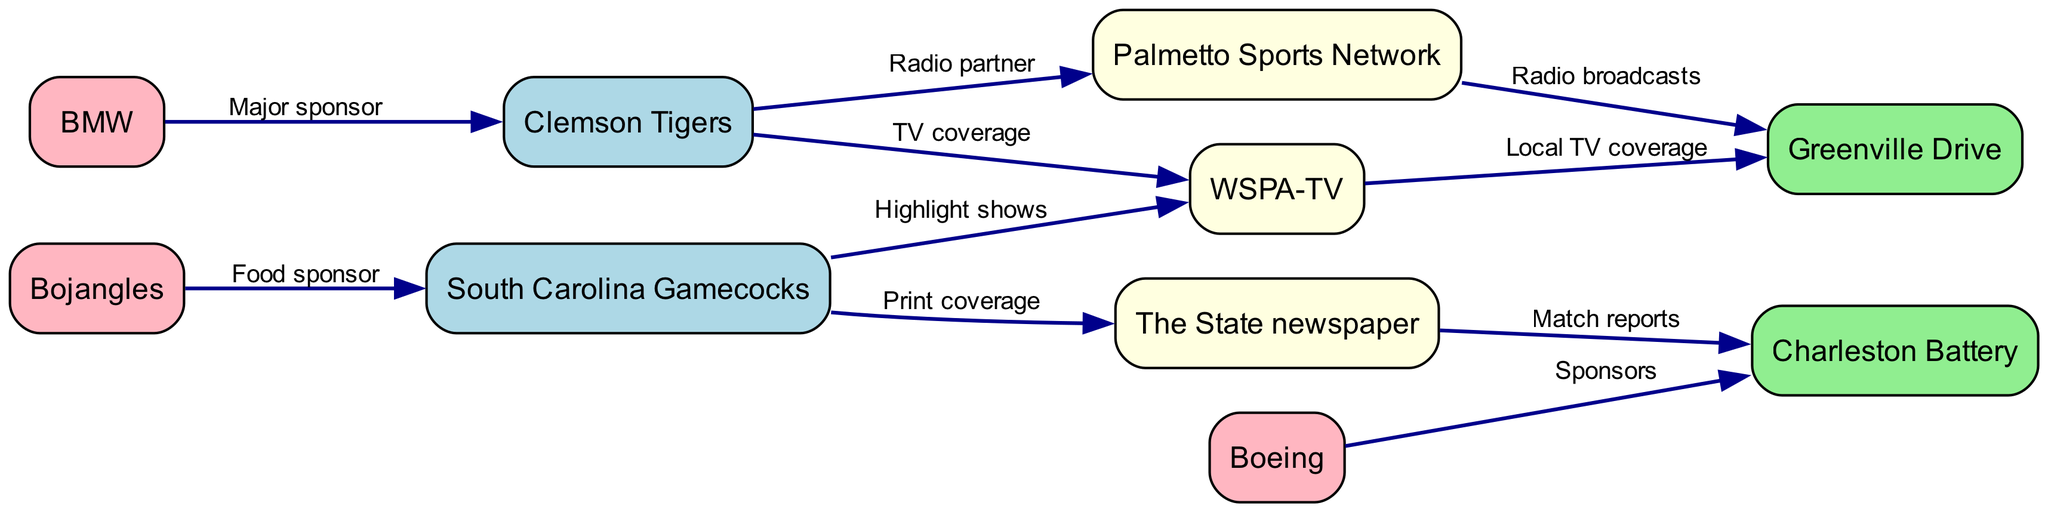What teams are covered by WSPA-TV? WSPA-TV has edges connecting it to Clemson Tigers and Greenville Drive, indicating that it provides TV coverage to both teams.
Answer: Clemson Tigers, Greenville Drive How many sponsors are listed in the diagram? The sponsors identified in the diagram are Boeing and BMW for Charleston Battery and Clemson Tigers respectively, and Bojangles for South Carolina Gamecocks. Counting these, there are three distinct sponsors in total.
Answer: 3 Which team has a radio partnership with Palmetto Sports Network? The edge connecting Clemson Tigers to Palmetto Sports Network indicates that Clemson Tigers has a radio partnership with this network.
Answer: Clemson Tigers What type of coverage does The State newspaper provide for Charleston Battery? The edge labeled "Match reports" from The State newspaper to Charleston Battery suggests that The State provides match reports for this team.
Answer: Match reports Which local media outlets provide coverage for South Carolina Gamecocks? The diagram shows two edges for South Carolina Gamecocks; one to WSPA-TV for highlight shows and another to The State newspaper for print coverage, indicating both provide coverage.
Answer: WSPA-TV, The State newspaper How many nodes are there for sports teams in the diagram? The nodes labeled as sports teams are Clemson Tigers, South Carolina Gamecocks, Charleston Battery, and Greenville Drive. There are a total of four distinct sports teams listed in the diagram.
Answer: 4 Which team has the most connections in terms of sponsorship? Examining the edges, we see that Clemson Tigers has an edge coming from BMW as a major sponsor, while South Carolina Gamecocks has Bojangles as a food sponsor. Therefore, Clemson Tigers has the highest sponsorship connection with BMW as the only major sponsor.
Answer: Clemson Tigers What is the relationship between Greenville Drive and Palmetto Sports Network? The edge labeled "Radio broadcasts" indicates that Palmetto Sports Network provides radio broadcasts for Greenville Drive, which defines their relationship.
Answer: Radio broadcasts How does WSPA-TV interact with the sports teams represented in the diagram? WSPA-TV interacts with two sports teams: it has an edge for TV coverage with Clemson Tigers and also provides local TV coverage for Greenville Drive, indicating its role in broadcast coverage for both teams.
Answer: TV coverage, Local TV coverage 